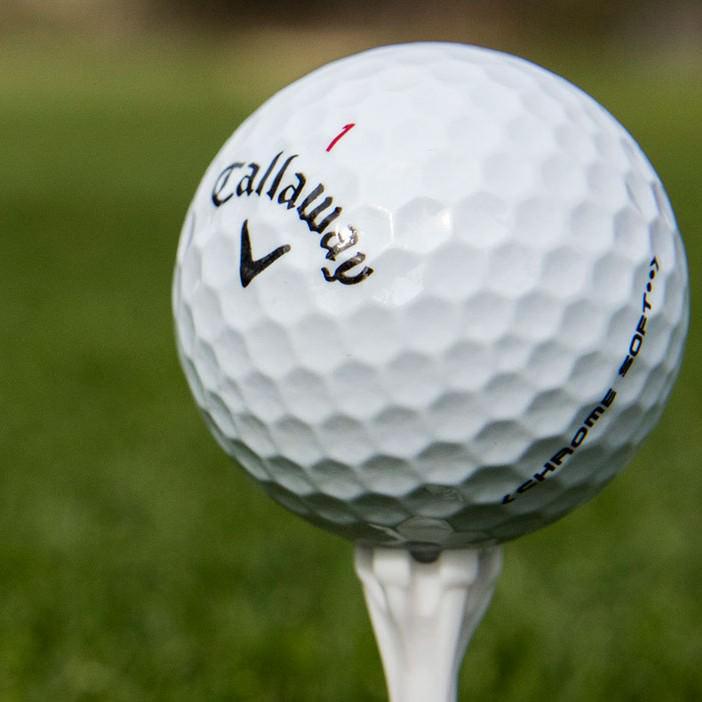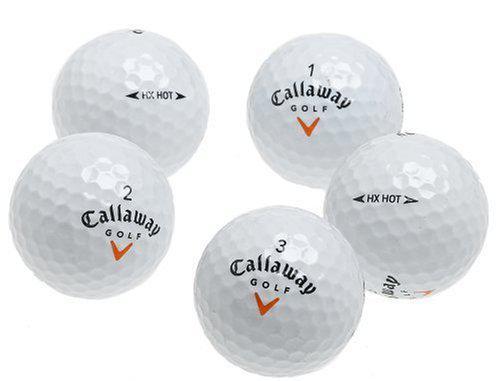The first image is the image on the left, the second image is the image on the right. Analyze the images presented: Is the assertion "there are exactly three balls in one of the images." valid? Answer yes or no. No. 